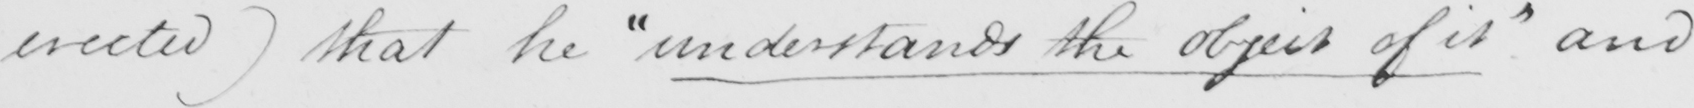Can you tell me what this handwritten text says? erected )  that he  " understands the object of it "  and 